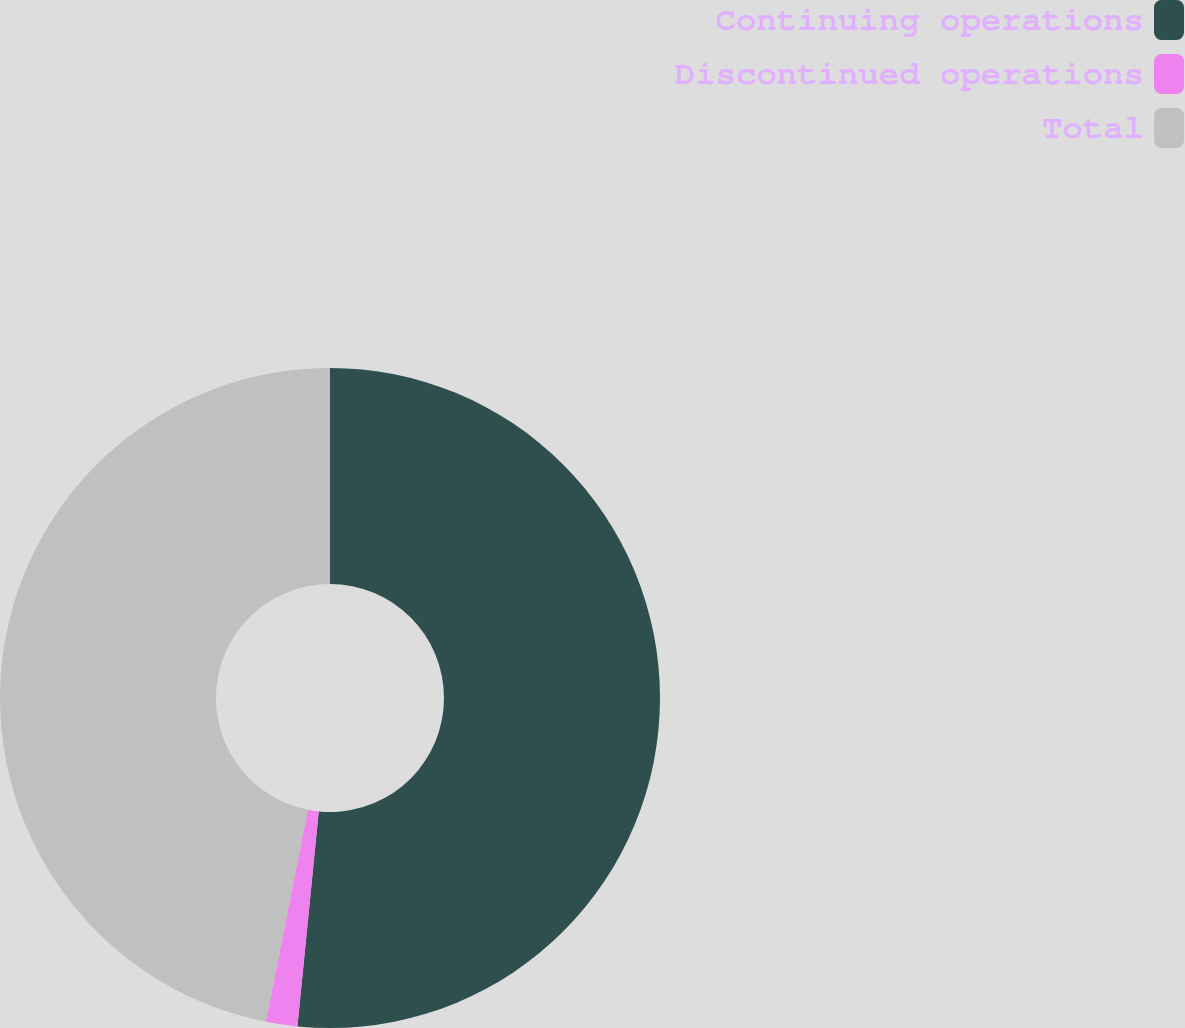<chart> <loc_0><loc_0><loc_500><loc_500><pie_chart><fcel>Continuing operations<fcel>Discontinued operations<fcel>Total<nl><fcel>51.57%<fcel>1.54%<fcel>46.88%<nl></chart> 